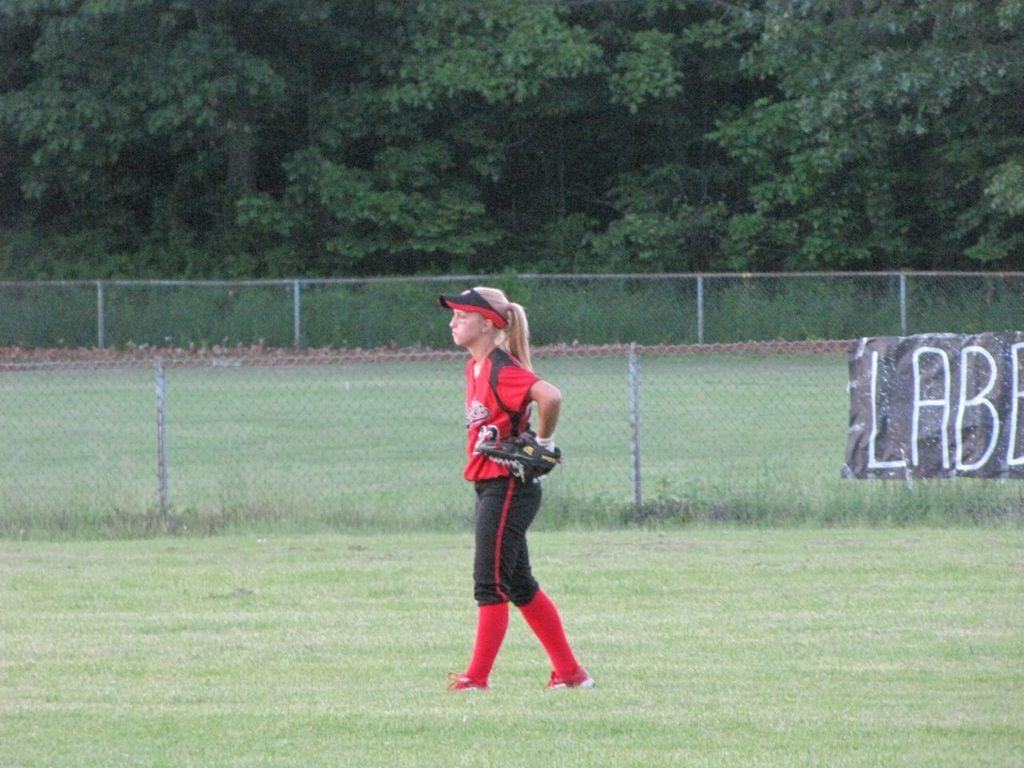Provide a one-sentence caption for the provided image. A girl in a baseball uniform of a red jersey and black pants stands in the outfield. 